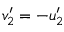Convert formula to latex. <formula><loc_0><loc_0><loc_500><loc_500>v _ { 2 } ^ { \prime } = - u _ { 2 } ^ { \prime }</formula> 